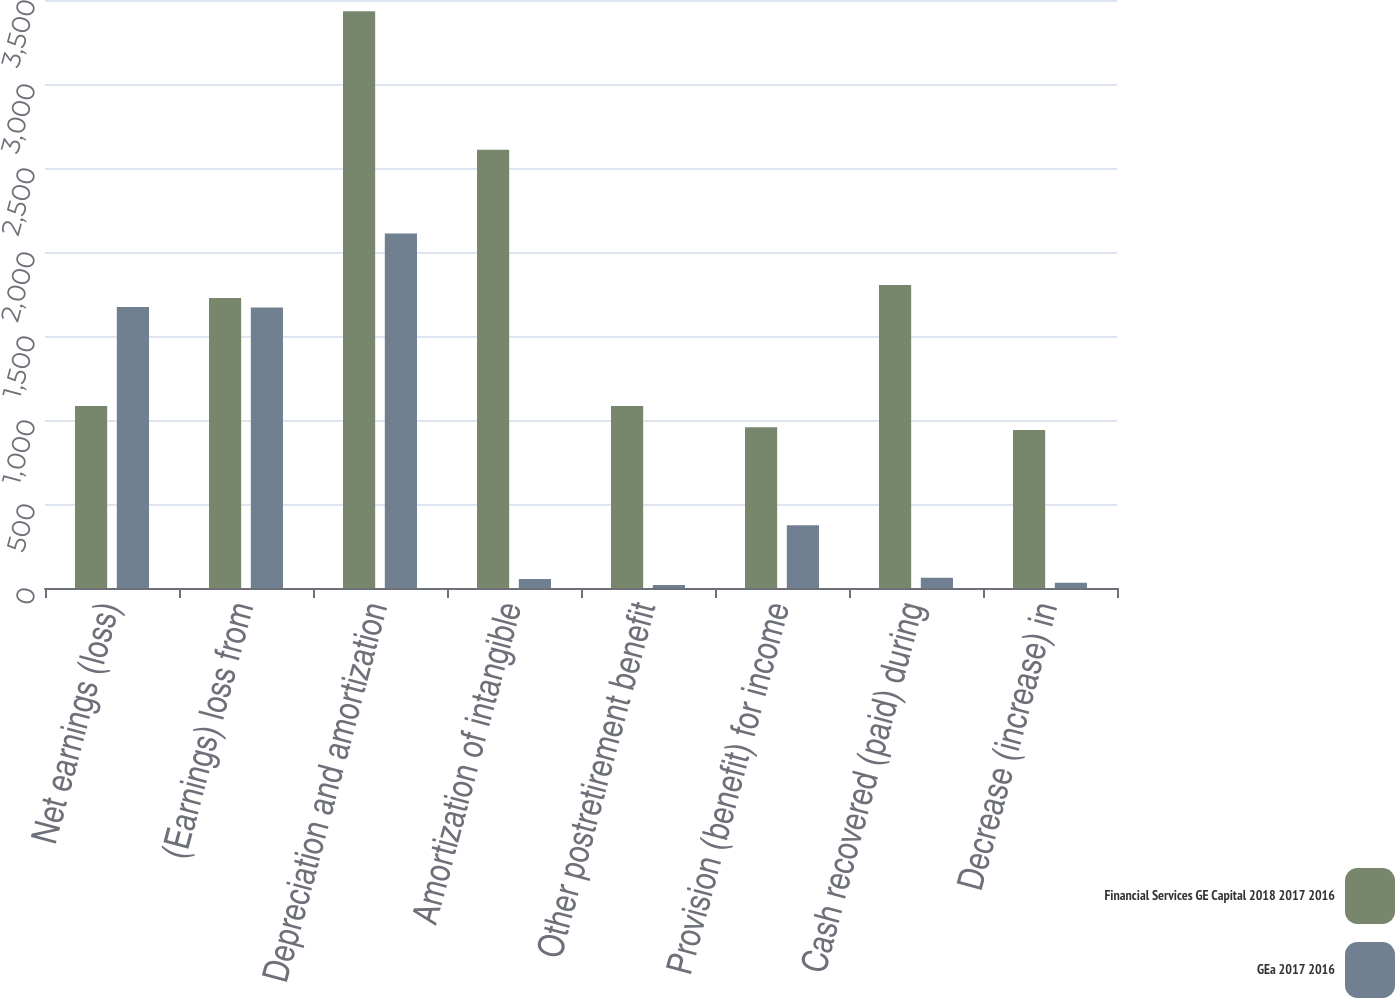Convert chart. <chart><loc_0><loc_0><loc_500><loc_500><stacked_bar_chart><ecel><fcel>Net earnings (loss)<fcel>(Earnings) loss from<fcel>Depreciation and amortization<fcel>Amortization of intangible<fcel>Other postretirement benefit<fcel>Provision (benefit) for income<fcel>Cash recovered (paid) during<fcel>Decrease (increase) in<nl><fcel>Financial Services GE Capital 2018 2017 2016<fcel>1084<fcel>1726<fcel>3433<fcel>2608<fcel>1084<fcel>957<fcel>1803<fcel>941<nl><fcel>GEa 2017 2016<fcel>1672<fcel>1670<fcel>2110<fcel>53<fcel>18<fcel>374<fcel>61<fcel>31<nl></chart> 